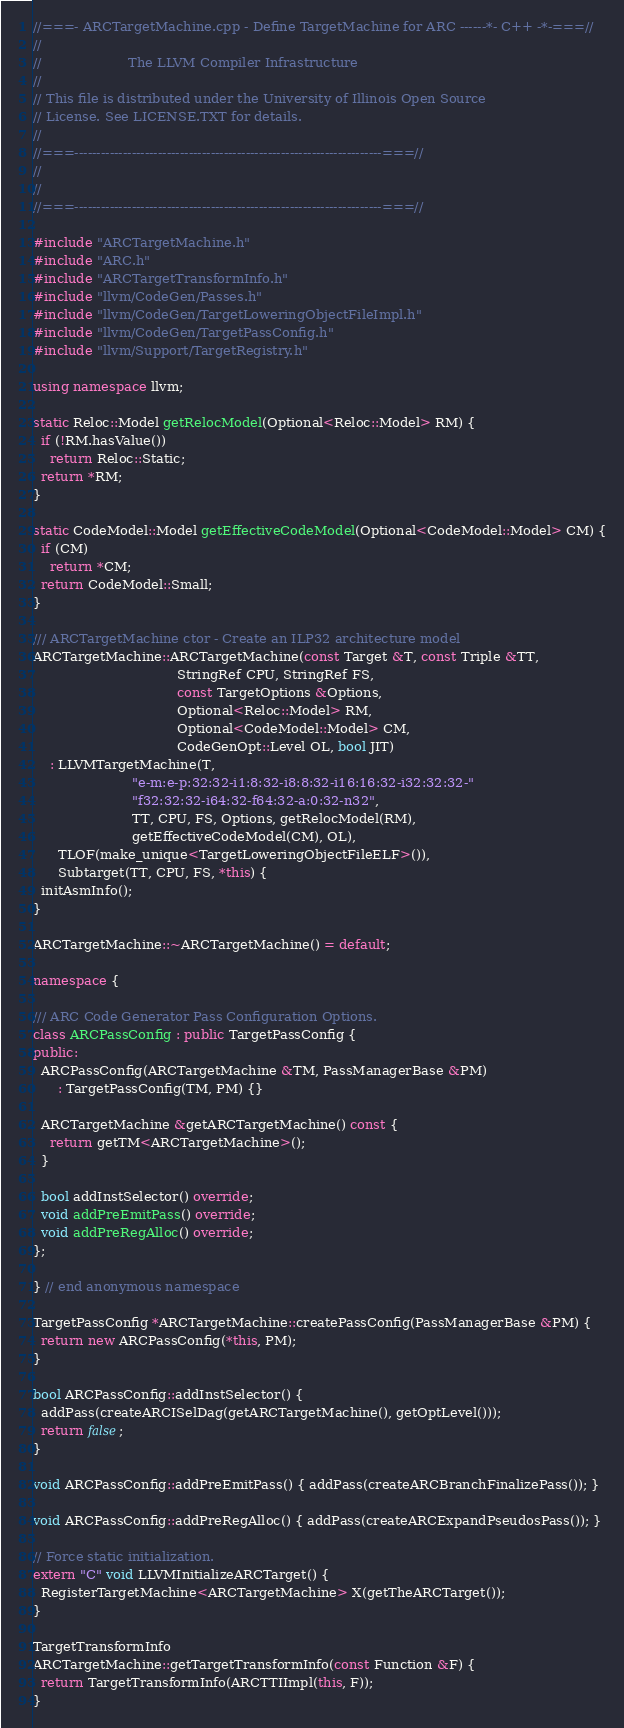<code> <loc_0><loc_0><loc_500><loc_500><_C++_>//===- ARCTargetMachine.cpp - Define TargetMachine for ARC ------*- C++ -*-===//
//
//                     The LLVM Compiler Infrastructure
//
// This file is distributed under the University of Illinois Open Source
// License. See LICENSE.TXT for details.
//
//===----------------------------------------------------------------------===//
//
//
//===----------------------------------------------------------------------===//

#include "ARCTargetMachine.h"
#include "ARC.h"
#include "ARCTargetTransformInfo.h"
#include "llvm/CodeGen/Passes.h"
#include "llvm/CodeGen/TargetLoweringObjectFileImpl.h"
#include "llvm/CodeGen/TargetPassConfig.h"
#include "llvm/Support/TargetRegistry.h"

using namespace llvm;

static Reloc::Model getRelocModel(Optional<Reloc::Model> RM) {
  if (!RM.hasValue())
    return Reloc::Static;
  return *RM;
}

static CodeModel::Model getEffectiveCodeModel(Optional<CodeModel::Model> CM) {
  if (CM)
    return *CM;
  return CodeModel::Small;
}

/// ARCTargetMachine ctor - Create an ILP32 architecture model
ARCTargetMachine::ARCTargetMachine(const Target &T, const Triple &TT,
                                   StringRef CPU, StringRef FS,
                                   const TargetOptions &Options,
                                   Optional<Reloc::Model> RM,
                                   Optional<CodeModel::Model> CM,
                                   CodeGenOpt::Level OL, bool JIT)
    : LLVMTargetMachine(T,
                        "e-m:e-p:32:32-i1:8:32-i8:8:32-i16:16:32-i32:32:32-"
                        "f32:32:32-i64:32-f64:32-a:0:32-n32",
                        TT, CPU, FS, Options, getRelocModel(RM),
                        getEffectiveCodeModel(CM), OL),
      TLOF(make_unique<TargetLoweringObjectFileELF>()),
      Subtarget(TT, CPU, FS, *this) {
  initAsmInfo();
}

ARCTargetMachine::~ARCTargetMachine() = default;

namespace {

/// ARC Code Generator Pass Configuration Options.
class ARCPassConfig : public TargetPassConfig {
public:
  ARCPassConfig(ARCTargetMachine &TM, PassManagerBase &PM)
      : TargetPassConfig(TM, PM) {}

  ARCTargetMachine &getARCTargetMachine() const {
    return getTM<ARCTargetMachine>();
  }

  bool addInstSelector() override;
  void addPreEmitPass() override;
  void addPreRegAlloc() override;
};

} // end anonymous namespace

TargetPassConfig *ARCTargetMachine::createPassConfig(PassManagerBase &PM) {
  return new ARCPassConfig(*this, PM);
}

bool ARCPassConfig::addInstSelector() {
  addPass(createARCISelDag(getARCTargetMachine(), getOptLevel()));
  return false;
}

void ARCPassConfig::addPreEmitPass() { addPass(createARCBranchFinalizePass()); }

void ARCPassConfig::addPreRegAlloc() { addPass(createARCExpandPseudosPass()); }

// Force static initialization.
extern "C" void LLVMInitializeARCTarget() {
  RegisterTargetMachine<ARCTargetMachine> X(getTheARCTarget());
}

TargetTransformInfo
ARCTargetMachine::getTargetTransformInfo(const Function &F) {
  return TargetTransformInfo(ARCTTIImpl(this, F));
}
</code> 